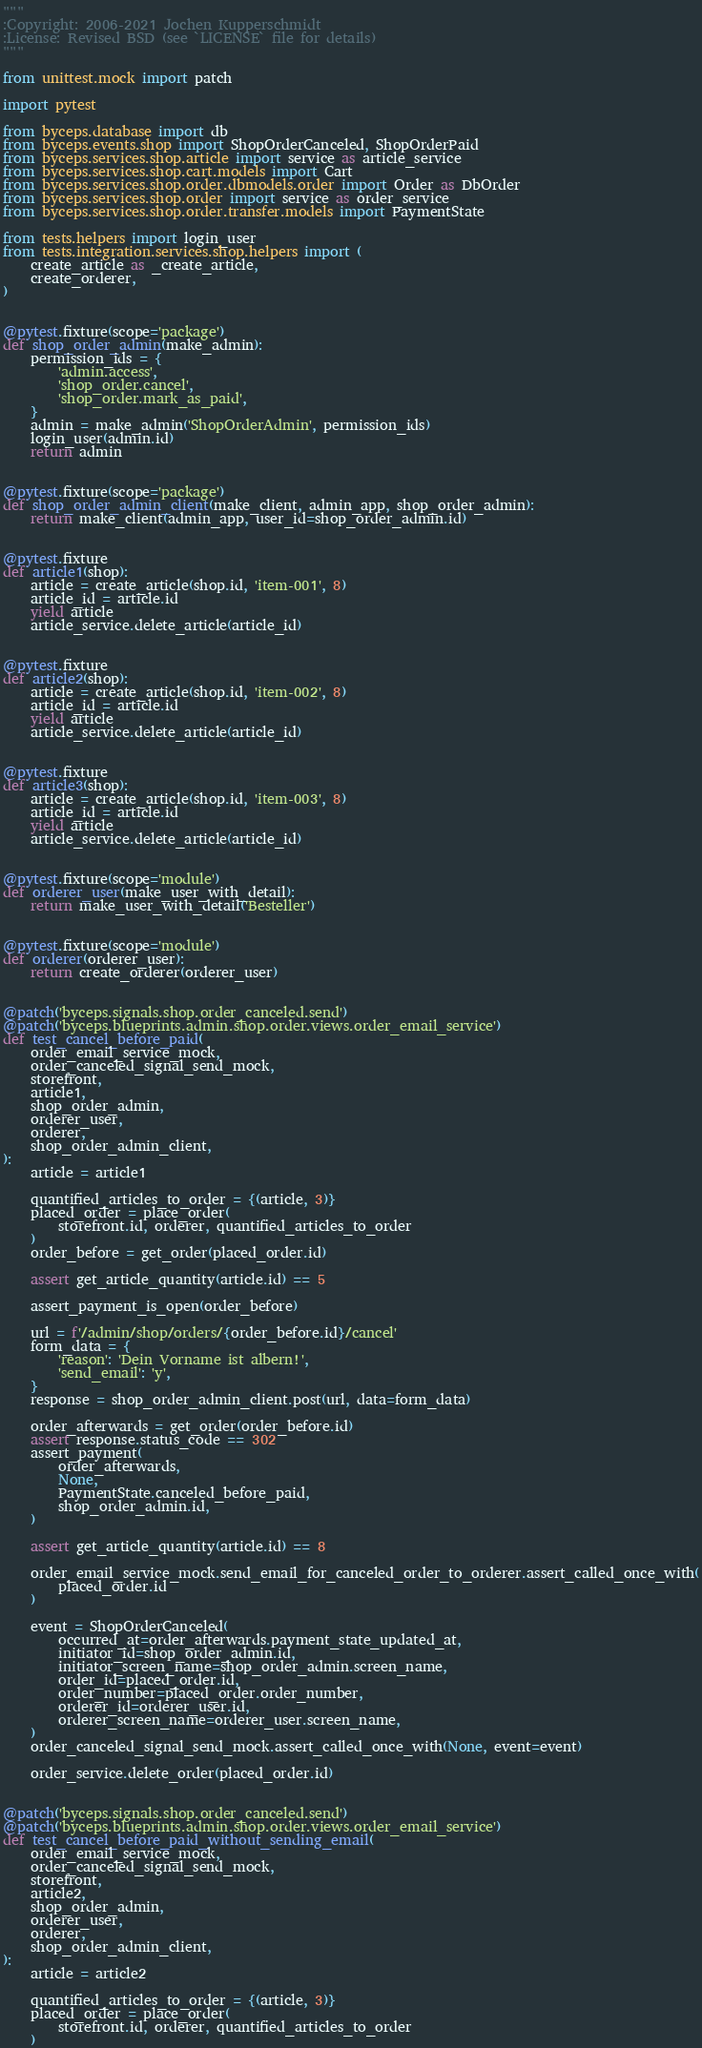<code> <loc_0><loc_0><loc_500><loc_500><_Python_>"""
:Copyright: 2006-2021 Jochen Kupperschmidt
:License: Revised BSD (see `LICENSE` file for details)
"""

from unittest.mock import patch

import pytest

from byceps.database import db
from byceps.events.shop import ShopOrderCanceled, ShopOrderPaid
from byceps.services.shop.article import service as article_service
from byceps.services.shop.cart.models import Cart
from byceps.services.shop.order.dbmodels.order import Order as DbOrder
from byceps.services.shop.order import service as order_service
from byceps.services.shop.order.transfer.models import PaymentState

from tests.helpers import login_user
from tests.integration.services.shop.helpers import (
    create_article as _create_article,
    create_orderer,
)


@pytest.fixture(scope='package')
def shop_order_admin(make_admin):
    permission_ids = {
        'admin.access',
        'shop_order.cancel',
        'shop_order.mark_as_paid',
    }
    admin = make_admin('ShopOrderAdmin', permission_ids)
    login_user(admin.id)
    return admin


@pytest.fixture(scope='package')
def shop_order_admin_client(make_client, admin_app, shop_order_admin):
    return make_client(admin_app, user_id=shop_order_admin.id)


@pytest.fixture
def article1(shop):
    article = create_article(shop.id, 'item-001', 8)
    article_id = article.id
    yield article
    article_service.delete_article(article_id)


@pytest.fixture
def article2(shop):
    article = create_article(shop.id, 'item-002', 8)
    article_id = article.id
    yield article
    article_service.delete_article(article_id)


@pytest.fixture
def article3(shop):
    article = create_article(shop.id, 'item-003', 8)
    article_id = article.id
    yield article
    article_service.delete_article(article_id)


@pytest.fixture(scope='module')
def orderer_user(make_user_with_detail):
    return make_user_with_detail('Besteller')


@pytest.fixture(scope='module')
def orderer(orderer_user):
    return create_orderer(orderer_user)


@patch('byceps.signals.shop.order_canceled.send')
@patch('byceps.blueprints.admin.shop.order.views.order_email_service')
def test_cancel_before_paid(
    order_email_service_mock,
    order_canceled_signal_send_mock,
    storefront,
    article1,
    shop_order_admin,
    orderer_user,
    orderer,
    shop_order_admin_client,
):
    article = article1

    quantified_articles_to_order = {(article, 3)}
    placed_order = place_order(
        storefront.id, orderer, quantified_articles_to_order
    )
    order_before = get_order(placed_order.id)

    assert get_article_quantity(article.id) == 5

    assert_payment_is_open(order_before)

    url = f'/admin/shop/orders/{order_before.id}/cancel'
    form_data = {
        'reason': 'Dein Vorname ist albern!',
        'send_email': 'y',
    }
    response = shop_order_admin_client.post(url, data=form_data)

    order_afterwards = get_order(order_before.id)
    assert response.status_code == 302
    assert_payment(
        order_afterwards,
        None,
        PaymentState.canceled_before_paid,
        shop_order_admin.id,
    )

    assert get_article_quantity(article.id) == 8

    order_email_service_mock.send_email_for_canceled_order_to_orderer.assert_called_once_with(
        placed_order.id
    )

    event = ShopOrderCanceled(
        occurred_at=order_afterwards.payment_state_updated_at,
        initiator_id=shop_order_admin.id,
        initiator_screen_name=shop_order_admin.screen_name,
        order_id=placed_order.id,
        order_number=placed_order.order_number,
        orderer_id=orderer_user.id,
        orderer_screen_name=orderer_user.screen_name,
    )
    order_canceled_signal_send_mock.assert_called_once_with(None, event=event)

    order_service.delete_order(placed_order.id)


@patch('byceps.signals.shop.order_canceled.send')
@patch('byceps.blueprints.admin.shop.order.views.order_email_service')
def test_cancel_before_paid_without_sending_email(
    order_email_service_mock,
    order_canceled_signal_send_mock,
    storefront,
    article2,
    shop_order_admin,
    orderer_user,
    orderer,
    shop_order_admin_client,
):
    article = article2

    quantified_articles_to_order = {(article, 3)}
    placed_order = place_order(
        storefront.id, orderer, quantified_articles_to_order
    )
</code> 